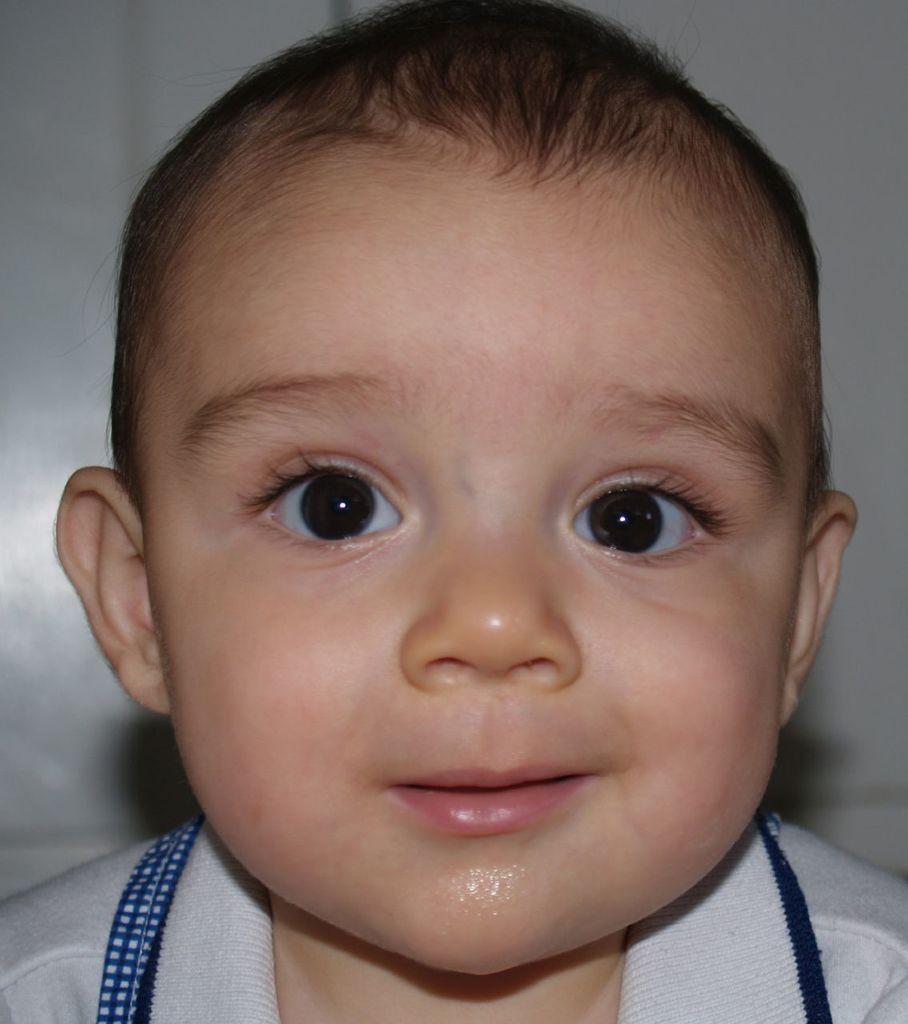What is the main subject of the image? The main subject of the image is a baby. What is the baby wearing in the image? The baby is wearing a white t-shirt. What is the baby's facial expression in the image? The baby is smiling in the image. What is the color of the background in the image? The background of the image is white in color. What type of texture can be seen on the baby's mask in the image? There is no mask present in the image, so it is not possible to determine the texture of a mask. 